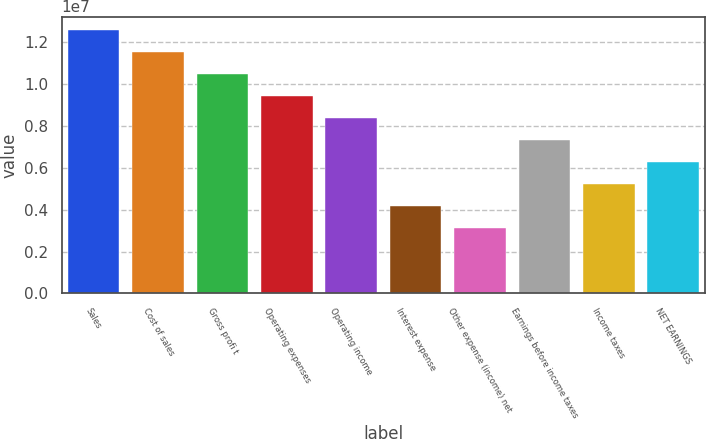<chart> <loc_0><loc_0><loc_500><loc_500><bar_chart><fcel>Sales<fcel>Cost of sales<fcel>Gross profi t<fcel>Operating expenses<fcel>Operating income<fcel>Interest expense<fcel>Other expense (income) net<fcel>Earnings before income taxes<fcel>Income taxes<fcel>NET EARNINGS<nl><fcel>1.26057e+07<fcel>1.15552e+07<fcel>1.05047e+07<fcel>9.45427e+06<fcel>8.4038e+06<fcel>4.2019e+06<fcel>3.15142e+06<fcel>7.35332e+06<fcel>5.25237e+06<fcel>6.30285e+06<nl></chart> 